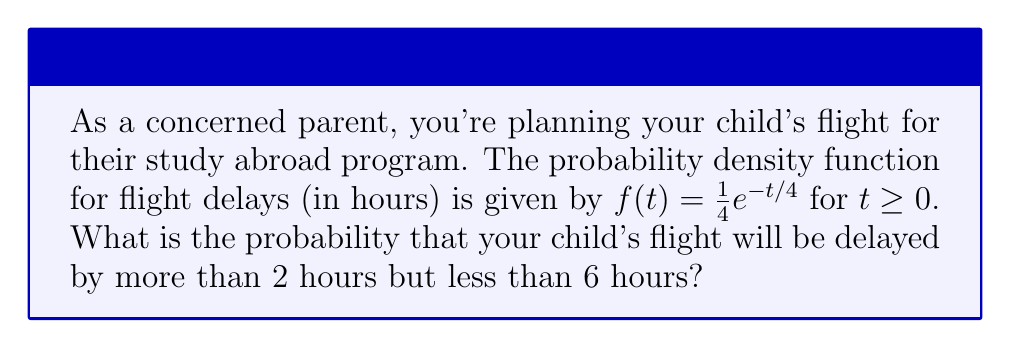Could you help me with this problem? To solve this problem, we need to integrate the probability density function over the given interval. Here's the step-by-step solution:

1) The probability of a delay between 2 and 6 hours is given by the integral:

   $$P(2 < T < 6) = \int_{2}^{6} f(t) dt = \int_{2}^{6} \frac{1}{4}e^{-t/4} dt$$

2) To integrate, we'll use the substitution method:
   Let $u = -t/4$, then $du = -\frac{1}{4}dt$ or $dt = -4du$

3) Changing the limits of integration:
   When $t = 2$, $u = -1/2$
   When $t = 6$, $u = -3/2$

4) Rewriting the integral:

   $$\int_{2}^{6} \frac{1}{4}e^{-t/4} dt = \int_{-3/2}^{-1/2} \frac{1}{4}e^u (-4du) = -\int_{-3/2}^{-1/2} e^u du$$

5) Integrate:

   $$-\int_{-3/2}^{-1/2} e^u du = -[e^u]_{-3/2}^{-1/2} = -(e^{-1/2} - e^{-3/2})$$

6) Simplify:

   $$-(e^{-1/2} - e^{-3/2}) = e^{-3/2} - e^{-1/2}$$

7) Calculate the final value:

   $$e^{-3/2} - e^{-1/2} \approx 0.2231 - 0.6065 \approx -0.3834$$

8) Take the absolute value (as probability is always positive):

   $$|e^{-3/2} - e^{-1/2}| \approx 0.3834$$

Therefore, the probability of a delay between 2 and 6 hours is approximately 0.3834 or 38.34%.
Answer: 0.3834 